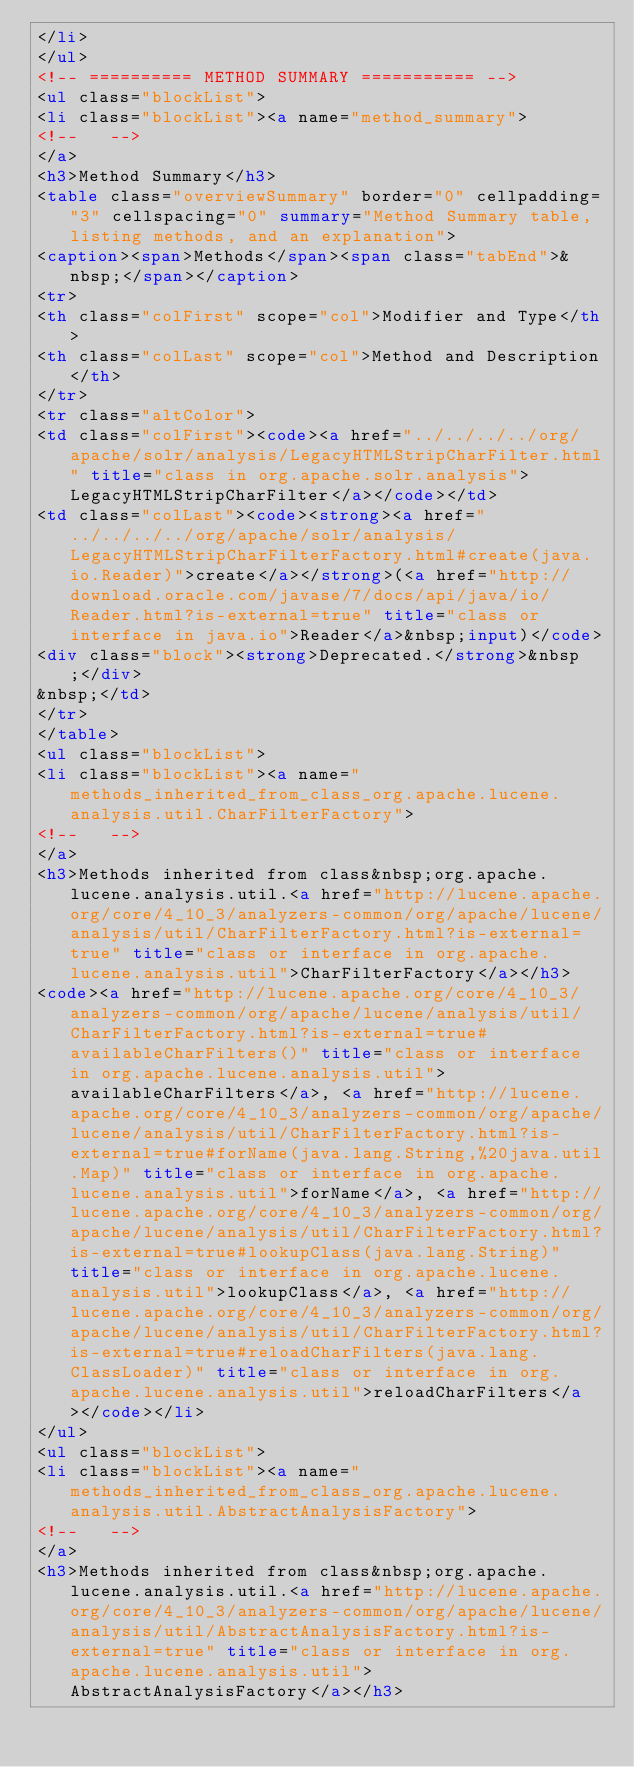<code> <loc_0><loc_0><loc_500><loc_500><_HTML_></li>
</ul>
<!-- ========== METHOD SUMMARY =========== -->
<ul class="blockList">
<li class="blockList"><a name="method_summary">
<!--   -->
</a>
<h3>Method Summary</h3>
<table class="overviewSummary" border="0" cellpadding="3" cellspacing="0" summary="Method Summary table, listing methods, and an explanation">
<caption><span>Methods</span><span class="tabEnd">&nbsp;</span></caption>
<tr>
<th class="colFirst" scope="col">Modifier and Type</th>
<th class="colLast" scope="col">Method and Description</th>
</tr>
<tr class="altColor">
<td class="colFirst"><code><a href="../../../../org/apache/solr/analysis/LegacyHTMLStripCharFilter.html" title="class in org.apache.solr.analysis">LegacyHTMLStripCharFilter</a></code></td>
<td class="colLast"><code><strong><a href="../../../../org/apache/solr/analysis/LegacyHTMLStripCharFilterFactory.html#create(java.io.Reader)">create</a></strong>(<a href="http://download.oracle.com/javase/7/docs/api/java/io/Reader.html?is-external=true" title="class or interface in java.io">Reader</a>&nbsp;input)</code>
<div class="block"><strong>Deprecated.</strong>&nbsp;</div>
&nbsp;</td>
</tr>
</table>
<ul class="blockList">
<li class="blockList"><a name="methods_inherited_from_class_org.apache.lucene.analysis.util.CharFilterFactory">
<!--   -->
</a>
<h3>Methods inherited from class&nbsp;org.apache.lucene.analysis.util.<a href="http://lucene.apache.org/core/4_10_3/analyzers-common/org/apache/lucene/analysis/util/CharFilterFactory.html?is-external=true" title="class or interface in org.apache.lucene.analysis.util">CharFilterFactory</a></h3>
<code><a href="http://lucene.apache.org/core/4_10_3/analyzers-common/org/apache/lucene/analysis/util/CharFilterFactory.html?is-external=true#availableCharFilters()" title="class or interface in org.apache.lucene.analysis.util">availableCharFilters</a>, <a href="http://lucene.apache.org/core/4_10_3/analyzers-common/org/apache/lucene/analysis/util/CharFilterFactory.html?is-external=true#forName(java.lang.String,%20java.util.Map)" title="class or interface in org.apache.lucene.analysis.util">forName</a>, <a href="http://lucene.apache.org/core/4_10_3/analyzers-common/org/apache/lucene/analysis/util/CharFilterFactory.html?is-external=true#lookupClass(java.lang.String)" title="class or interface in org.apache.lucene.analysis.util">lookupClass</a>, <a href="http://lucene.apache.org/core/4_10_3/analyzers-common/org/apache/lucene/analysis/util/CharFilterFactory.html?is-external=true#reloadCharFilters(java.lang.ClassLoader)" title="class or interface in org.apache.lucene.analysis.util">reloadCharFilters</a></code></li>
</ul>
<ul class="blockList">
<li class="blockList"><a name="methods_inherited_from_class_org.apache.lucene.analysis.util.AbstractAnalysisFactory">
<!--   -->
</a>
<h3>Methods inherited from class&nbsp;org.apache.lucene.analysis.util.<a href="http://lucene.apache.org/core/4_10_3/analyzers-common/org/apache/lucene/analysis/util/AbstractAnalysisFactory.html?is-external=true" title="class or interface in org.apache.lucene.analysis.util">AbstractAnalysisFactory</a></h3></code> 